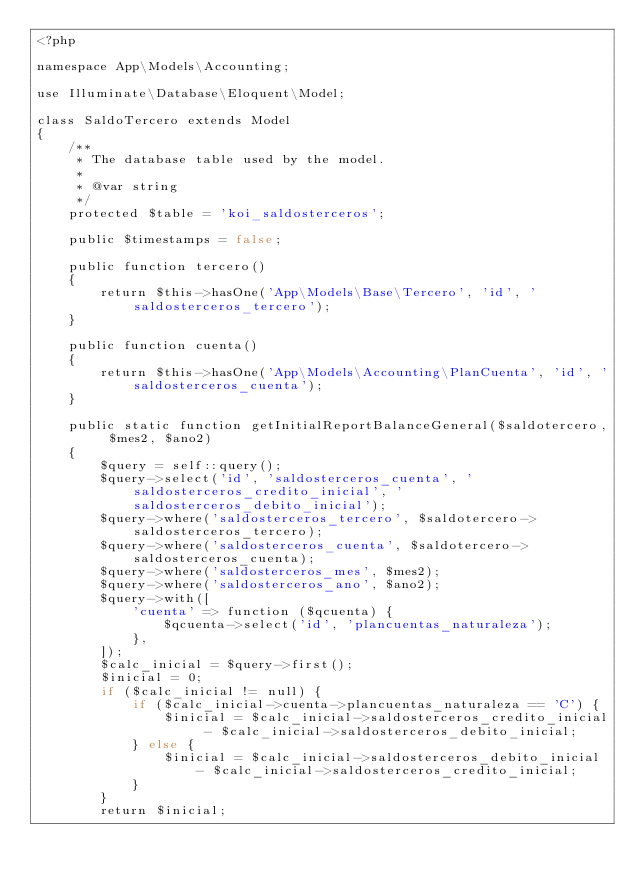Convert code to text. <code><loc_0><loc_0><loc_500><loc_500><_PHP_><?php

namespace App\Models\Accounting;

use Illuminate\Database\Eloquent\Model;

class SaldoTercero extends Model
{
    /**
     * The database table used by the model.
     *
     * @var string
     */
    protected $table = 'koi_saldosterceros';

    public $timestamps = false;

    public function tercero()
    {
        return $this->hasOne('App\Models\Base\Tercero', 'id', 'saldosterceros_tercero');
    }

    public function cuenta()
    {
        return $this->hasOne('App\Models\Accounting\PlanCuenta', 'id', 'saldosterceros_cuenta');
    }

    public static function getInitialReportBalanceGeneral($saldotercero, $mes2, $ano2)
    {
        $query = self::query();
        $query->select('id', 'saldosterceros_cuenta', 'saldosterceros_credito_inicial', 'saldosterceros_debito_inicial');
        $query->where('saldosterceros_tercero', $saldotercero->saldosterceros_tercero);
        $query->where('saldosterceros_cuenta', $saldotercero->saldosterceros_cuenta);
        $query->where('saldosterceros_mes', $mes2);
        $query->where('saldosterceros_ano', $ano2);
        $query->with([
            'cuenta' => function ($qcuenta) {
                $qcuenta->select('id', 'plancuentas_naturaleza');
            },
        ]);
        $calc_inicial = $query->first();
        $inicial = 0;
        if ($calc_inicial != null) {
            if ($calc_inicial->cuenta->plancuentas_naturaleza == 'C') {
                $inicial = $calc_inicial->saldosterceros_credito_inicial - $calc_inicial->saldosterceros_debito_inicial;
            } else {
                $inicial = $calc_inicial->saldosterceros_debito_inicial - $calc_inicial->saldosterceros_credito_inicial;
            }
        }
        return $inicial;</code> 